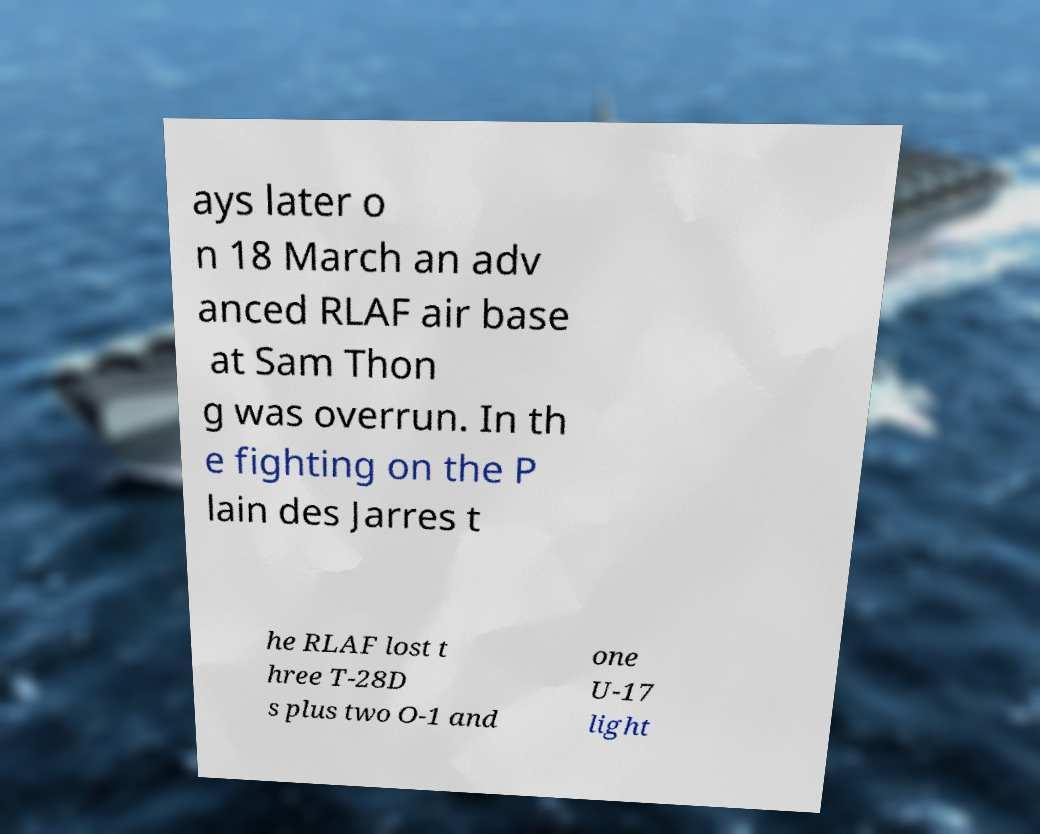I need the written content from this picture converted into text. Can you do that? ays later o n 18 March an adv anced RLAF air base at Sam Thon g was overrun. In th e fighting on the P lain des Jarres t he RLAF lost t hree T-28D s plus two O-1 and one U-17 light 